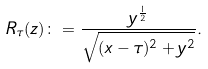Convert formula to latex. <formula><loc_0><loc_0><loc_500><loc_500>R _ { \tau } ( z ) \colon = \frac { y ^ { \frac { 1 } { 2 } } } { \sqrt { ( x - \tau ) ^ { 2 } + y ^ { 2 } } } .</formula> 